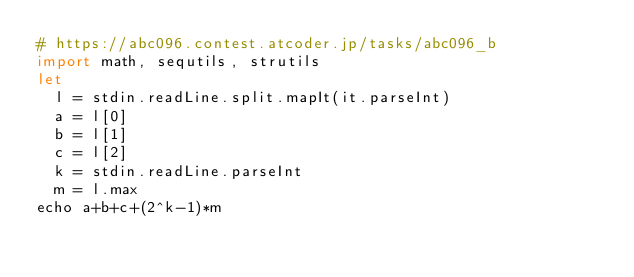<code> <loc_0><loc_0><loc_500><loc_500><_Nim_># https://abc096.contest.atcoder.jp/tasks/abc096_b
import math, sequtils, strutils
let
  l = stdin.readLine.split.mapIt(it.parseInt)
  a = l[0]
  b = l[1]
  c = l[2]
  k = stdin.readLine.parseInt
  m = l.max
echo a+b+c+(2^k-1)*m
</code> 